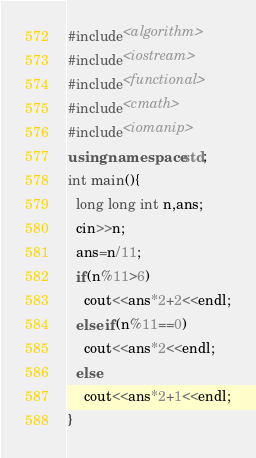Convert code to text. <code><loc_0><loc_0><loc_500><loc_500><_C++_>#include<algorithm>
#include<iostream>
#include<functional>
#include<cmath>
#include<iomanip>
using namespace std;
int main(){
  long long int n,ans;
  cin>>n;
  ans=n/11;
  if(n%11>6)
    cout<<ans*2+2<<endl;
  else if(n%11==0)
    cout<<ans*2<<endl;
  else
    cout<<ans*2+1<<endl;
}</code> 